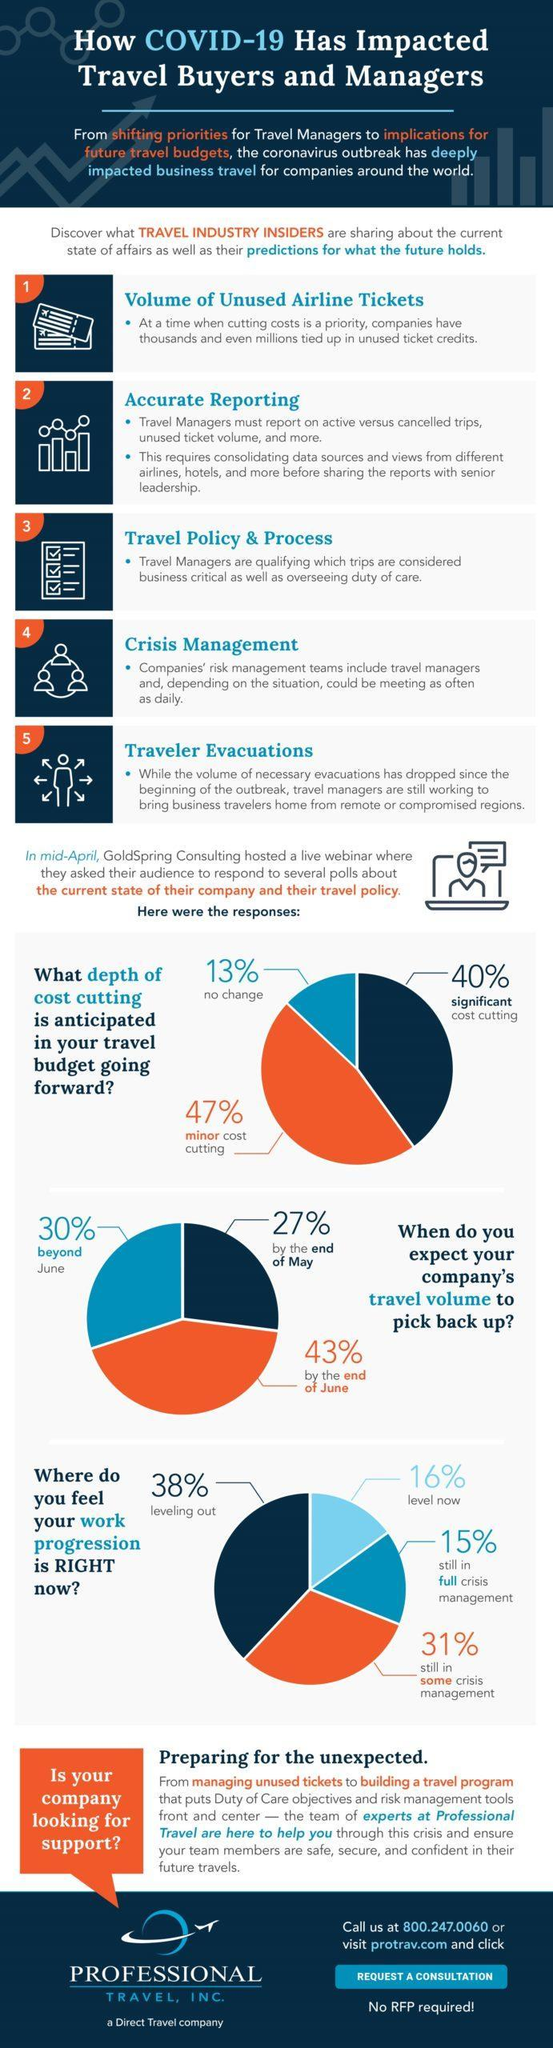Which has the highest share- beyond June, by the end of June?
Answer the question with a short phrase. by the end of June Which has the highest share- still in some crisis management, leveling out? leveling out Which has the highest share- significant cost-cutting, minor cost-cutting? minor cost cutting 